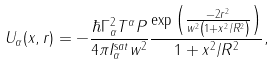<formula> <loc_0><loc_0><loc_500><loc_500>U _ { \alpha } ( x , r ) = - \frac { \hbar { \Gamma } _ { \alpha } ^ { 2 } T ^ { \alpha } P } { 4 \pi I _ { \alpha } ^ { \mathrm s a t } w ^ { 2 } } \frac { \exp \left ( \frac { - 2 r ^ { 2 } } { w ^ { 2 } \left ( 1 + x ^ { 2 } / R ^ { 2 } \right ) } \right ) } { 1 + x ^ { 2 } / R ^ { 2 } } ,</formula> 